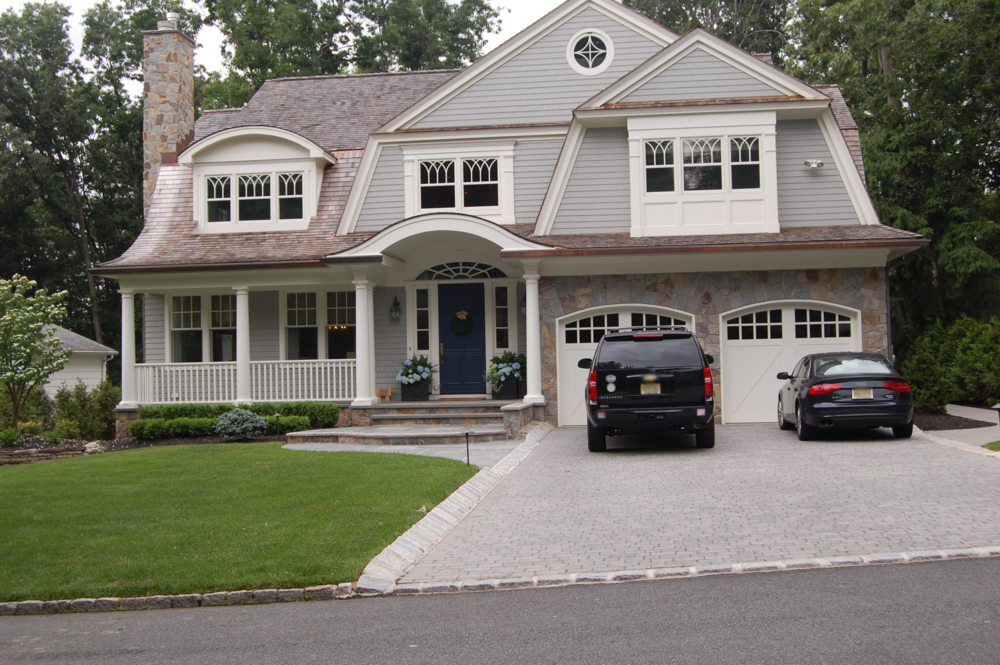Imagine the current homeowners are hosting a grand garden party. Describe the scene, including how the house and its features contribute to the atmosphere. The house and its stunning features create the perfect backdrop for a grand garden party. Lanterns are strung across the front porch and trees, casting a warm and inviting glow over the garden. Guests mingle on the meticulously manicured lawn, where tables are elegantly set with fresh flowers and fine linens. The sound of soft music drifts from the house, blending with the babbling of a small fountain nearby. The covered porch provides a cozy area for more intimate conversations, adorned with comfortable seating and soft lighting. Inside, the house is opened up, with large windows revealing the lively scene outside, making it a seamless fusion of indoor and outdoor spaces. The overall ambiance is magical and enchanting, leaving guests with a memorable experience. What would the menu look like for such an event? For a grand garden party at this elegant house, the menu would be both sophisticated and delicious. Starters might include delicate canapés and fresh, colorful salads featuring seasonal ingredients. Main courses could range from elegant seafood dishes, such as grilled salmon or shrimp scampi, to tender cuts of meat like filet mignon or herb-roasted chicken. Vegetarian options like stuffed bell peppers and quinoa-stuffed mushrooms would also be available. The dessert table would be a highlight, adorned with an array of sweets such as fruit tarts, chocolate mousse, and a signature cake. To complement the meal, a selection of fine wines, refreshing cocktails, and non-alcoholic beverages such as infused water and fresh-squeezed lemonade would be served. The attention to culinary detail would enhance the luxurious feel of the event, making it a night to remember. 